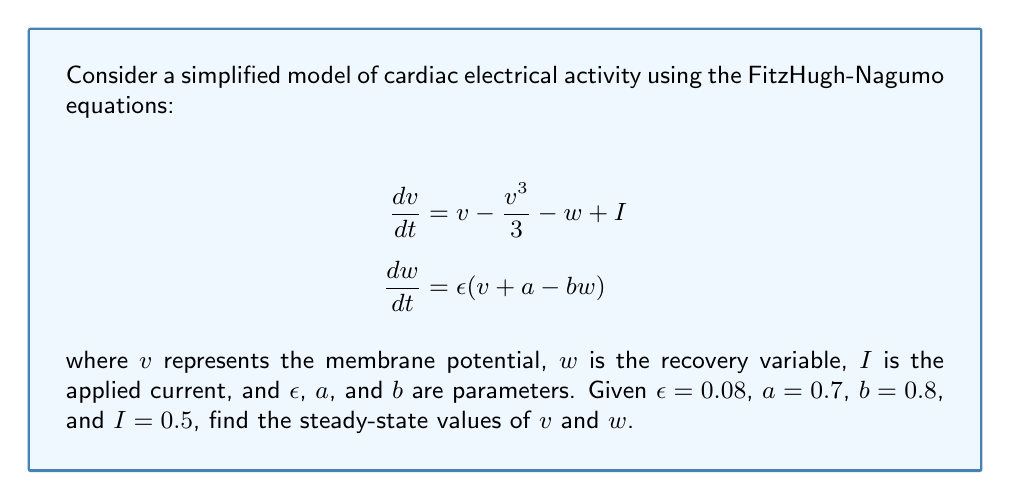Could you help me with this problem? To find the steady-state values, we need to set the time derivatives to zero:

1) Set $\frac{dv}{dt} = 0$ and $\frac{dw}{dt} = 0$:

   $$\begin{align}
   0 &= v - \frac{v^3}{3} - w + I \\
   0 &= \epsilon(v + a - bw)
   \end{align}$$

2) From the second equation:
   
   $$\begin{align}
   0 &= v + a - bw \\
   w &= \frac{v + a}{b}
   \end{align}$$

3) Substitute this into the first equation:

   $$\begin{align}
   0 &= v - \frac{v^3}{3} - \frac{v + a}{b} + I \\
   0 &= v - \frac{v^3}{3} - \frac{v + 0.7}{0.8} + 0.5
   \end{align}$$

4) Multiply by 3 to eliminate fractions:

   $$0 = 3v - v^3 - \frac{3(v + 0.7)}{0.8} + 1.5$$

5) Multiply by 0.8:

   $$0 = 2.4v - 0.8v^3 - 3v - 2.1 + 1.2$$

6) Simplify:

   $$0 = -0.8v^3 - 0.6v - 0.9$$

7) This cubic equation can be solved numerically. Using a root-finding method (e.g., Newton-Raphson), we find $v \approx 1.199$.

8) Substitute this value back into the equation for $w$:

   $$w = \frac{1.199 + 0.7}{0.8} \approx 2.374$$

Therefore, the steady-state values are approximately $v = 1.199$ and $w = 2.374$.
Answer: $v \approx 1.199$, $w \approx 2.374$ 